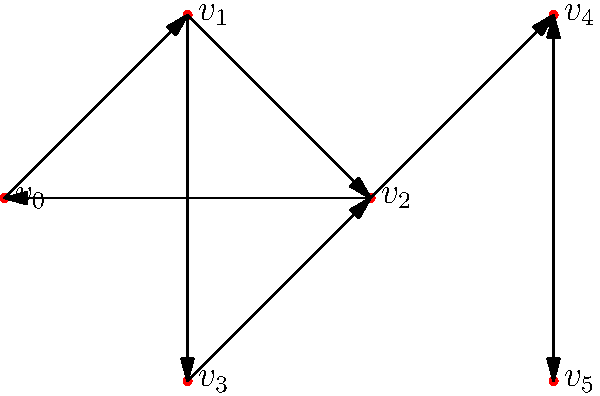Given the directed graph above, identify the strongly connected components (SCCs). Write a Python function `find_sccs(graph)` that takes a graph represented as a dictionary of adjacency lists and returns a list of SCCs, where each SCC is a list of vertex indices. How many SCCs does this graph have? To find the strongly connected components (SCCs) in a directed graph, we can use Kosaraju's algorithm. Here's a step-by-step explanation:

1. Perform a depth-first search (DFS) on the original graph to compute finishing times for each vertex.
2. Transpose the graph (reverse all edge directions).
3. Perform a DFS on the transposed graph, starting with the vertex that has the highest finishing time.

Let's implement this in Python:

```python
from collections import defaultdict

def dfs(graph, v, visited, stack):
    visited[v] = True
    for neighbor in graph[v]:
        if not visited[neighbor]:
            dfs(graph, neighbor, visited, stack)
    stack.append(v)

def transpose_graph(graph):
    transposed = defaultdict(list)
    for v in graph:
        for neighbor in graph[v]:
            transposed[neighbor].append(v)
    return transposed

def find_sccs(graph):
    stack = []
    visited = defaultdict(bool)
    
    # Step 1: DFS to fill stack
    for v in graph:
        if not visited[v]:
            dfs(graph, v, visited, stack)
    
    # Step 2: Transpose graph
    transposed = transpose_graph(graph)
    
    # Step 3: DFS on transposed graph
    visited = defaultdict(bool)
    sccs = []
    
    while stack:
        v = stack.pop()
        if not visited[v]:
            component = []
            dfs(transposed, v, visited, component)
            sccs.append(component)
    
    return sccs

# Example usage
graph = {
    0: [1],
    1: [2, 3],
    2: [0, 4],
    3: [2],
    4: [5],
    5: [4]
}

sccs = find_sccs(graph)
print(f"Number of SCCs: {len(sccs)}")
print(f"SCCs: {sccs}")
```

Applying this to our graph:

1. The first SCC is $\{v_0, v_1, v_2\}$ as they form a cycle.
2. The second SCC is $\{v_3\}$ as it doesn't have a path back to itself or any other component.
3. The third SCC is $\{v_4, v_5\}$ as they form a cycle.

Therefore, this graph has 3 strongly connected components.
Answer: 3 SCCs: $\{v_0, v_1, v_2\}$, $\{v_3\}$, $\{v_4, v_5\}$ 